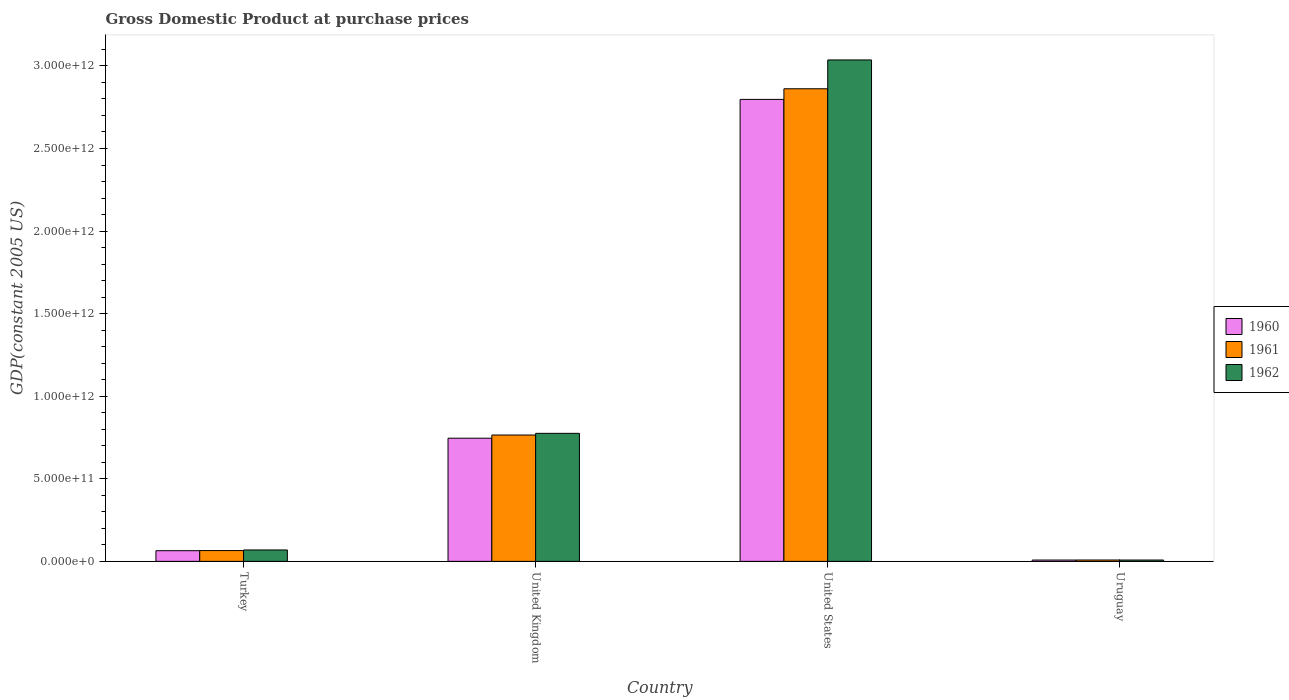How many groups of bars are there?
Give a very brief answer. 4. Are the number of bars on each tick of the X-axis equal?
Your answer should be very brief. Yes. How many bars are there on the 2nd tick from the left?
Your answer should be compact. 3. What is the GDP at purchase prices in 1962 in United States?
Offer a terse response. 3.04e+12. Across all countries, what is the maximum GDP at purchase prices in 1962?
Your response must be concise. 3.04e+12. Across all countries, what is the minimum GDP at purchase prices in 1961?
Keep it short and to the point. 8.20e+09. In which country was the GDP at purchase prices in 1962 minimum?
Ensure brevity in your answer.  Uruguay. What is the total GDP at purchase prices in 1962 in the graph?
Make the answer very short. 3.89e+12. What is the difference between the GDP at purchase prices in 1960 in United States and that in Uruguay?
Give a very brief answer. 2.79e+12. What is the difference between the GDP at purchase prices in 1960 in United Kingdom and the GDP at purchase prices in 1961 in Turkey?
Offer a very short reply. 6.80e+11. What is the average GDP at purchase prices in 1961 per country?
Your response must be concise. 9.25e+11. What is the difference between the GDP at purchase prices of/in 1960 and GDP at purchase prices of/in 1961 in United Kingdom?
Your answer should be very brief. -1.92e+1. In how many countries, is the GDP at purchase prices in 1962 greater than 800000000000 US$?
Your response must be concise. 1. What is the ratio of the GDP at purchase prices in 1960 in United Kingdom to that in Uruguay?
Offer a terse response. 93.21. Is the GDP at purchase prices in 1961 in United Kingdom less than that in Uruguay?
Make the answer very short. No. Is the difference between the GDP at purchase prices in 1960 in United States and Uruguay greater than the difference between the GDP at purchase prices in 1961 in United States and Uruguay?
Make the answer very short. No. What is the difference between the highest and the second highest GDP at purchase prices in 1960?
Provide a succinct answer. -2.05e+12. What is the difference between the highest and the lowest GDP at purchase prices in 1960?
Give a very brief answer. 2.79e+12. Is the sum of the GDP at purchase prices in 1960 in Turkey and Uruguay greater than the maximum GDP at purchase prices in 1961 across all countries?
Ensure brevity in your answer.  No. What does the 3rd bar from the left in United Kingdom represents?
Provide a short and direct response. 1962. Is it the case that in every country, the sum of the GDP at purchase prices in 1962 and GDP at purchase prices in 1960 is greater than the GDP at purchase prices in 1961?
Ensure brevity in your answer.  Yes. What is the difference between two consecutive major ticks on the Y-axis?
Keep it short and to the point. 5.00e+11. Are the values on the major ticks of Y-axis written in scientific E-notation?
Ensure brevity in your answer.  Yes. Where does the legend appear in the graph?
Offer a very short reply. Center right. What is the title of the graph?
Give a very brief answer. Gross Domestic Product at purchase prices. What is the label or title of the Y-axis?
Make the answer very short. GDP(constant 2005 US). What is the GDP(constant 2005 US) of 1960 in Turkey?
Make the answer very short. 6.46e+1. What is the GDP(constant 2005 US) in 1961 in Turkey?
Your answer should be compact. 6.54e+1. What is the GDP(constant 2005 US) of 1962 in Turkey?
Give a very brief answer. 6.90e+1. What is the GDP(constant 2005 US) of 1960 in United Kingdom?
Keep it short and to the point. 7.46e+11. What is the GDP(constant 2005 US) in 1961 in United Kingdom?
Give a very brief answer. 7.65e+11. What is the GDP(constant 2005 US) of 1962 in United Kingdom?
Offer a very short reply. 7.75e+11. What is the GDP(constant 2005 US) of 1960 in United States?
Offer a terse response. 2.80e+12. What is the GDP(constant 2005 US) in 1961 in United States?
Keep it short and to the point. 2.86e+12. What is the GDP(constant 2005 US) of 1962 in United States?
Your response must be concise. 3.04e+12. What is the GDP(constant 2005 US) of 1960 in Uruguay?
Offer a terse response. 8.00e+09. What is the GDP(constant 2005 US) in 1961 in Uruguay?
Offer a terse response. 8.20e+09. What is the GDP(constant 2005 US) of 1962 in Uruguay?
Provide a succinct answer. 8.07e+09. Across all countries, what is the maximum GDP(constant 2005 US) of 1960?
Provide a short and direct response. 2.80e+12. Across all countries, what is the maximum GDP(constant 2005 US) in 1961?
Your answer should be compact. 2.86e+12. Across all countries, what is the maximum GDP(constant 2005 US) in 1962?
Keep it short and to the point. 3.04e+12. Across all countries, what is the minimum GDP(constant 2005 US) of 1960?
Make the answer very short. 8.00e+09. Across all countries, what is the minimum GDP(constant 2005 US) in 1961?
Provide a succinct answer. 8.20e+09. Across all countries, what is the minimum GDP(constant 2005 US) in 1962?
Your answer should be compact. 8.07e+09. What is the total GDP(constant 2005 US) in 1960 in the graph?
Make the answer very short. 3.62e+12. What is the total GDP(constant 2005 US) in 1961 in the graph?
Your response must be concise. 3.70e+12. What is the total GDP(constant 2005 US) of 1962 in the graph?
Offer a terse response. 3.89e+12. What is the difference between the GDP(constant 2005 US) in 1960 in Turkey and that in United Kingdom?
Keep it short and to the point. -6.81e+11. What is the difference between the GDP(constant 2005 US) of 1961 in Turkey and that in United Kingdom?
Your answer should be very brief. -7.00e+11. What is the difference between the GDP(constant 2005 US) of 1962 in Turkey and that in United Kingdom?
Provide a short and direct response. -7.06e+11. What is the difference between the GDP(constant 2005 US) of 1960 in Turkey and that in United States?
Provide a succinct answer. -2.73e+12. What is the difference between the GDP(constant 2005 US) in 1961 in Turkey and that in United States?
Give a very brief answer. -2.80e+12. What is the difference between the GDP(constant 2005 US) in 1962 in Turkey and that in United States?
Keep it short and to the point. -2.97e+12. What is the difference between the GDP(constant 2005 US) in 1960 in Turkey and that in Uruguay?
Offer a terse response. 5.66e+1. What is the difference between the GDP(constant 2005 US) of 1961 in Turkey and that in Uruguay?
Your answer should be very brief. 5.72e+1. What is the difference between the GDP(constant 2005 US) of 1962 in Turkey and that in Uruguay?
Your answer should be very brief. 6.09e+1. What is the difference between the GDP(constant 2005 US) of 1960 in United Kingdom and that in United States?
Your answer should be compact. -2.05e+12. What is the difference between the GDP(constant 2005 US) in 1961 in United Kingdom and that in United States?
Provide a succinct answer. -2.10e+12. What is the difference between the GDP(constant 2005 US) in 1962 in United Kingdom and that in United States?
Offer a very short reply. -2.26e+12. What is the difference between the GDP(constant 2005 US) in 1960 in United Kingdom and that in Uruguay?
Offer a very short reply. 7.38e+11. What is the difference between the GDP(constant 2005 US) of 1961 in United Kingdom and that in Uruguay?
Provide a succinct answer. 7.57e+11. What is the difference between the GDP(constant 2005 US) in 1962 in United Kingdom and that in Uruguay?
Provide a succinct answer. 7.67e+11. What is the difference between the GDP(constant 2005 US) in 1960 in United States and that in Uruguay?
Provide a succinct answer. 2.79e+12. What is the difference between the GDP(constant 2005 US) in 1961 in United States and that in Uruguay?
Your response must be concise. 2.85e+12. What is the difference between the GDP(constant 2005 US) of 1962 in United States and that in Uruguay?
Provide a short and direct response. 3.03e+12. What is the difference between the GDP(constant 2005 US) in 1960 in Turkey and the GDP(constant 2005 US) in 1961 in United Kingdom?
Provide a short and direct response. -7.00e+11. What is the difference between the GDP(constant 2005 US) in 1960 in Turkey and the GDP(constant 2005 US) in 1962 in United Kingdom?
Provide a short and direct response. -7.11e+11. What is the difference between the GDP(constant 2005 US) of 1961 in Turkey and the GDP(constant 2005 US) of 1962 in United Kingdom?
Ensure brevity in your answer.  -7.10e+11. What is the difference between the GDP(constant 2005 US) of 1960 in Turkey and the GDP(constant 2005 US) of 1961 in United States?
Your answer should be compact. -2.80e+12. What is the difference between the GDP(constant 2005 US) of 1960 in Turkey and the GDP(constant 2005 US) of 1962 in United States?
Provide a short and direct response. -2.97e+12. What is the difference between the GDP(constant 2005 US) of 1961 in Turkey and the GDP(constant 2005 US) of 1962 in United States?
Your answer should be compact. -2.97e+12. What is the difference between the GDP(constant 2005 US) of 1960 in Turkey and the GDP(constant 2005 US) of 1961 in Uruguay?
Your response must be concise. 5.64e+1. What is the difference between the GDP(constant 2005 US) in 1960 in Turkey and the GDP(constant 2005 US) in 1962 in Uruguay?
Make the answer very short. 5.66e+1. What is the difference between the GDP(constant 2005 US) in 1961 in Turkey and the GDP(constant 2005 US) in 1962 in Uruguay?
Your answer should be compact. 5.73e+1. What is the difference between the GDP(constant 2005 US) in 1960 in United Kingdom and the GDP(constant 2005 US) in 1961 in United States?
Make the answer very short. -2.12e+12. What is the difference between the GDP(constant 2005 US) of 1960 in United Kingdom and the GDP(constant 2005 US) of 1962 in United States?
Ensure brevity in your answer.  -2.29e+12. What is the difference between the GDP(constant 2005 US) in 1961 in United Kingdom and the GDP(constant 2005 US) in 1962 in United States?
Offer a very short reply. -2.27e+12. What is the difference between the GDP(constant 2005 US) of 1960 in United Kingdom and the GDP(constant 2005 US) of 1961 in Uruguay?
Your answer should be compact. 7.38e+11. What is the difference between the GDP(constant 2005 US) in 1960 in United Kingdom and the GDP(constant 2005 US) in 1962 in Uruguay?
Your answer should be very brief. 7.38e+11. What is the difference between the GDP(constant 2005 US) of 1961 in United Kingdom and the GDP(constant 2005 US) of 1962 in Uruguay?
Offer a very short reply. 7.57e+11. What is the difference between the GDP(constant 2005 US) of 1960 in United States and the GDP(constant 2005 US) of 1961 in Uruguay?
Keep it short and to the point. 2.79e+12. What is the difference between the GDP(constant 2005 US) in 1960 in United States and the GDP(constant 2005 US) in 1962 in Uruguay?
Offer a very short reply. 2.79e+12. What is the difference between the GDP(constant 2005 US) of 1961 in United States and the GDP(constant 2005 US) of 1962 in Uruguay?
Your answer should be compact. 2.85e+12. What is the average GDP(constant 2005 US) of 1960 per country?
Give a very brief answer. 9.04e+11. What is the average GDP(constant 2005 US) of 1961 per country?
Provide a succinct answer. 9.25e+11. What is the average GDP(constant 2005 US) in 1962 per country?
Provide a succinct answer. 9.72e+11. What is the difference between the GDP(constant 2005 US) of 1960 and GDP(constant 2005 US) of 1961 in Turkey?
Offer a terse response. -7.47e+08. What is the difference between the GDP(constant 2005 US) of 1960 and GDP(constant 2005 US) of 1962 in Turkey?
Your response must be concise. -4.39e+09. What is the difference between the GDP(constant 2005 US) of 1961 and GDP(constant 2005 US) of 1962 in Turkey?
Offer a very short reply. -3.64e+09. What is the difference between the GDP(constant 2005 US) in 1960 and GDP(constant 2005 US) in 1961 in United Kingdom?
Provide a short and direct response. -1.92e+1. What is the difference between the GDP(constant 2005 US) of 1960 and GDP(constant 2005 US) of 1962 in United Kingdom?
Offer a terse response. -2.94e+1. What is the difference between the GDP(constant 2005 US) in 1961 and GDP(constant 2005 US) in 1962 in United Kingdom?
Keep it short and to the point. -1.02e+1. What is the difference between the GDP(constant 2005 US) of 1960 and GDP(constant 2005 US) of 1961 in United States?
Make the answer very short. -6.43e+1. What is the difference between the GDP(constant 2005 US) in 1960 and GDP(constant 2005 US) in 1962 in United States?
Offer a very short reply. -2.39e+11. What is the difference between the GDP(constant 2005 US) of 1961 and GDP(constant 2005 US) of 1962 in United States?
Give a very brief answer. -1.75e+11. What is the difference between the GDP(constant 2005 US) in 1960 and GDP(constant 2005 US) in 1961 in Uruguay?
Make the answer very short. -1.99e+08. What is the difference between the GDP(constant 2005 US) in 1960 and GDP(constant 2005 US) in 1962 in Uruguay?
Offer a terse response. -7.04e+07. What is the difference between the GDP(constant 2005 US) in 1961 and GDP(constant 2005 US) in 1962 in Uruguay?
Give a very brief answer. 1.29e+08. What is the ratio of the GDP(constant 2005 US) in 1960 in Turkey to that in United Kingdom?
Your answer should be compact. 0.09. What is the ratio of the GDP(constant 2005 US) in 1961 in Turkey to that in United Kingdom?
Ensure brevity in your answer.  0.09. What is the ratio of the GDP(constant 2005 US) in 1962 in Turkey to that in United Kingdom?
Provide a short and direct response. 0.09. What is the ratio of the GDP(constant 2005 US) in 1960 in Turkey to that in United States?
Your response must be concise. 0.02. What is the ratio of the GDP(constant 2005 US) of 1961 in Turkey to that in United States?
Give a very brief answer. 0.02. What is the ratio of the GDP(constant 2005 US) in 1962 in Turkey to that in United States?
Provide a succinct answer. 0.02. What is the ratio of the GDP(constant 2005 US) in 1960 in Turkey to that in Uruguay?
Ensure brevity in your answer.  8.08. What is the ratio of the GDP(constant 2005 US) of 1961 in Turkey to that in Uruguay?
Your answer should be compact. 7.97. What is the ratio of the GDP(constant 2005 US) in 1962 in Turkey to that in Uruguay?
Your answer should be very brief. 8.55. What is the ratio of the GDP(constant 2005 US) of 1960 in United Kingdom to that in United States?
Give a very brief answer. 0.27. What is the ratio of the GDP(constant 2005 US) of 1961 in United Kingdom to that in United States?
Provide a succinct answer. 0.27. What is the ratio of the GDP(constant 2005 US) in 1962 in United Kingdom to that in United States?
Make the answer very short. 0.26. What is the ratio of the GDP(constant 2005 US) in 1960 in United Kingdom to that in Uruguay?
Ensure brevity in your answer.  93.21. What is the ratio of the GDP(constant 2005 US) in 1961 in United Kingdom to that in Uruguay?
Keep it short and to the point. 93.28. What is the ratio of the GDP(constant 2005 US) in 1962 in United Kingdom to that in Uruguay?
Give a very brief answer. 96.03. What is the ratio of the GDP(constant 2005 US) in 1960 in United States to that in Uruguay?
Keep it short and to the point. 349.58. What is the ratio of the GDP(constant 2005 US) of 1961 in United States to that in Uruguay?
Your answer should be compact. 348.93. What is the ratio of the GDP(constant 2005 US) of 1962 in United States to that in Uruguay?
Provide a short and direct response. 376.13. What is the difference between the highest and the second highest GDP(constant 2005 US) of 1960?
Your answer should be compact. 2.05e+12. What is the difference between the highest and the second highest GDP(constant 2005 US) of 1961?
Your answer should be compact. 2.10e+12. What is the difference between the highest and the second highest GDP(constant 2005 US) in 1962?
Give a very brief answer. 2.26e+12. What is the difference between the highest and the lowest GDP(constant 2005 US) in 1960?
Offer a terse response. 2.79e+12. What is the difference between the highest and the lowest GDP(constant 2005 US) of 1961?
Make the answer very short. 2.85e+12. What is the difference between the highest and the lowest GDP(constant 2005 US) of 1962?
Your answer should be very brief. 3.03e+12. 